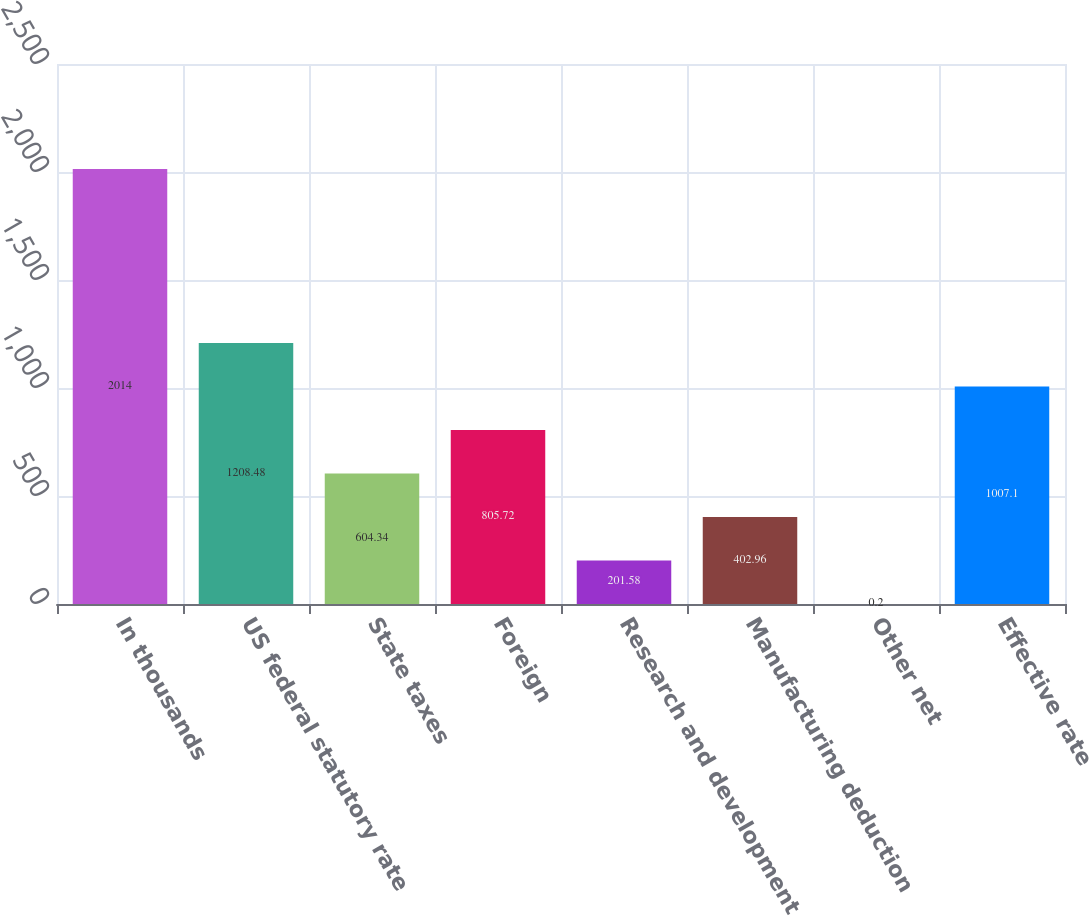Convert chart to OTSL. <chart><loc_0><loc_0><loc_500><loc_500><bar_chart><fcel>In thousands<fcel>US federal statutory rate<fcel>State taxes<fcel>Foreign<fcel>Research and development<fcel>Manufacturing deduction<fcel>Other net<fcel>Effective rate<nl><fcel>2014<fcel>1208.48<fcel>604.34<fcel>805.72<fcel>201.58<fcel>402.96<fcel>0.2<fcel>1007.1<nl></chart> 